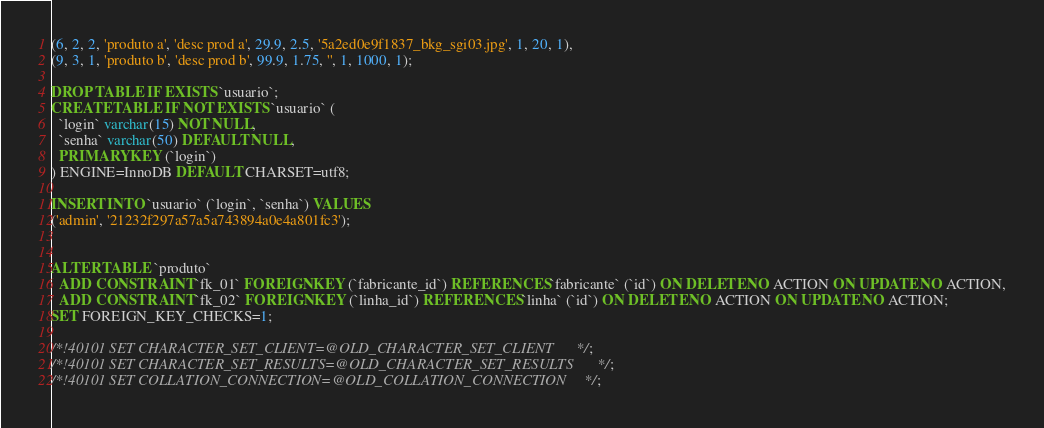Convert code to text. <code><loc_0><loc_0><loc_500><loc_500><_SQL_>(6, 2, 2, 'produto a', 'desc prod a', 29.9, 2.5, '5a2ed0e9f1837_bkg_sgi03.jpg', 1, 20, 1),
(9, 3, 1, 'produto b', 'desc prod b', 99.9, 1.75, '', 1, 1000, 1);

DROP TABLE IF EXISTS `usuario`;
CREATE TABLE IF NOT EXISTS `usuario` (
  `login` varchar(15) NOT NULL,
  `senha` varchar(50) DEFAULT NULL,
  PRIMARY KEY (`login`)
) ENGINE=InnoDB DEFAULT CHARSET=utf8;

INSERT INTO `usuario` (`login`, `senha`) VALUES
('admin', '21232f297a57a5a743894a0e4a801fc3');


ALTER TABLE `produto`
  ADD CONSTRAINT `fk_01` FOREIGN KEY (`fabricante_id`) REFERENCES `fabricante` (`id`) ON DELETE NO ACTION ON UPDATE NO ACTION,
  ADD CONSTRAINT `fk_02` FOREIGN KEY (`linha_id`) REFERENCES `linha` (`id`) ON DELETE NO ACTION ON UPDATE NO ACTION;
SET FOREIGN_KEY_CHECKS=1;

/*!40101 SET CHARACTER_SET_CLIENT=@OLD_CHARACTER_SET_CLIENT */;
/*!40101 SET CHARACTER_SET_RESULTS=@OLD_CHARACTER_SET_RESULTS */;
/*!40101 SET COLLATION_CONNECTION=@OLD_COLLATION_CONNECTION */;
</code> 